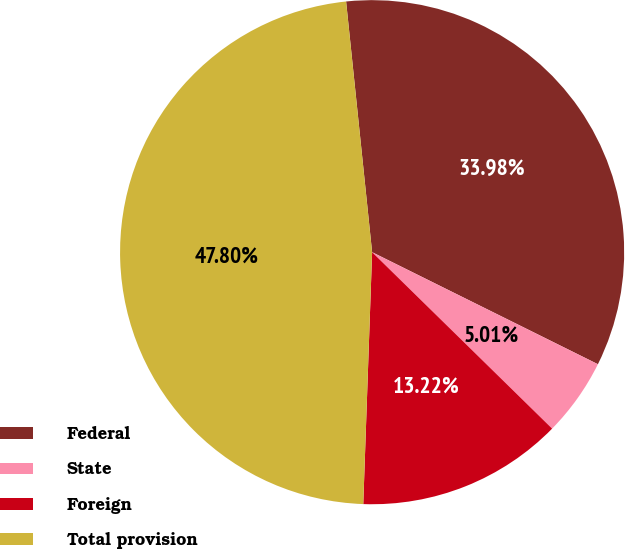Convert chart. <chart><loc_0><loc_0><loc_500><loc_500><pie_chart><fcel>Federal<fcel>State<fcel>Foreign<fcel>Total provision<nl><fcel>33.98%<fcel>5.01%<fcel>13.22%<fcel>47.8%<nl></chart> 